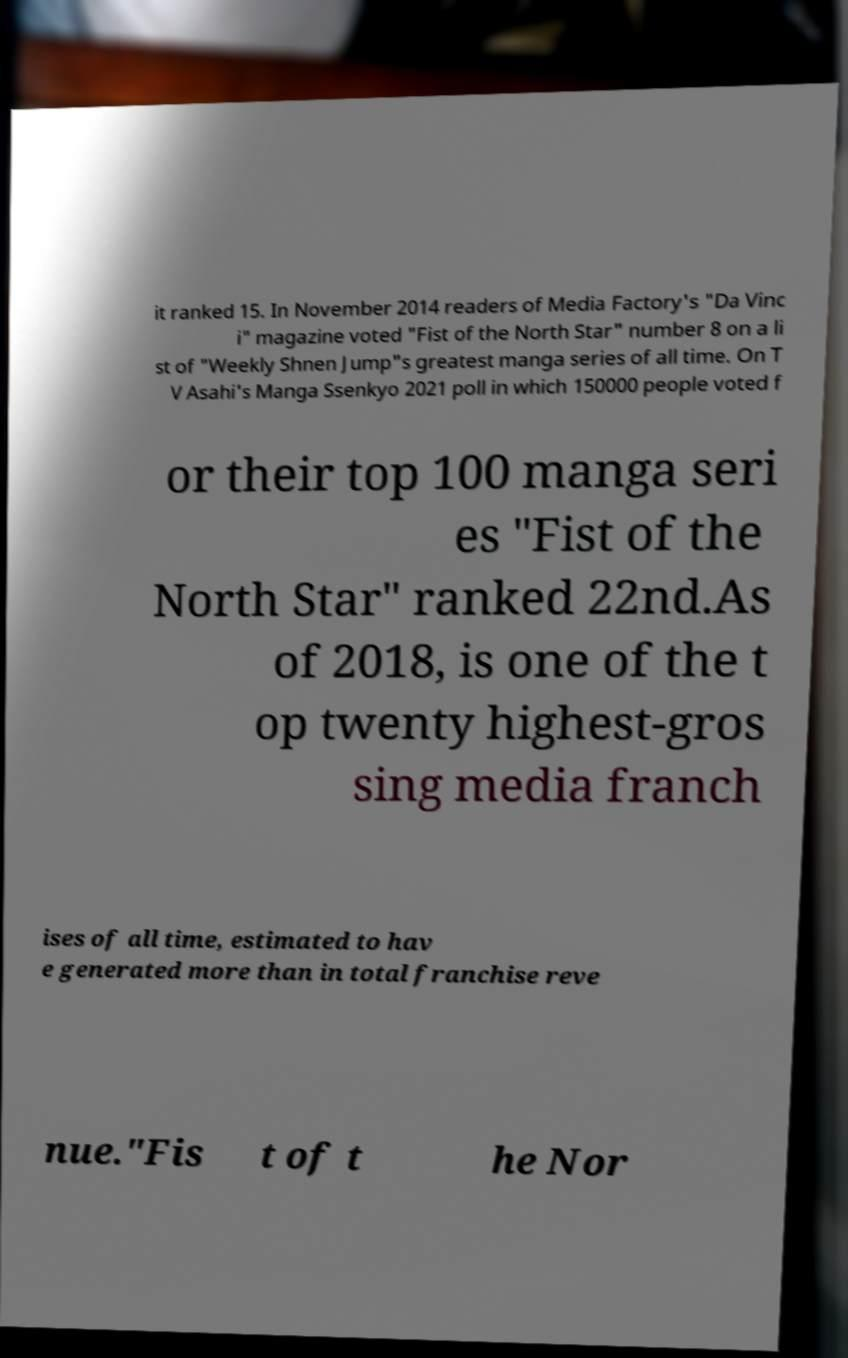Could you assist in decoding the text presented in this image and type it out clearly? it ranked 15. In November 2014 readers of Media Factory's "Da Vinc i" magazine voted "Fist of the North Star" number 8 on a li st of "Weekly Shnen Jump"s greatest manga series of all time. On T V Asahi's Manga Ssenkyo 2021 poll in which 150000 people voted f or their top 100 manga seri es "Fist of the North Star" ranked 22nd.As of 2018, is one of the t op twenty highest-gros sing media franch ises of all time, estimated to hav e generated more than in total franchise reve nue."Fis t of t he Nor 